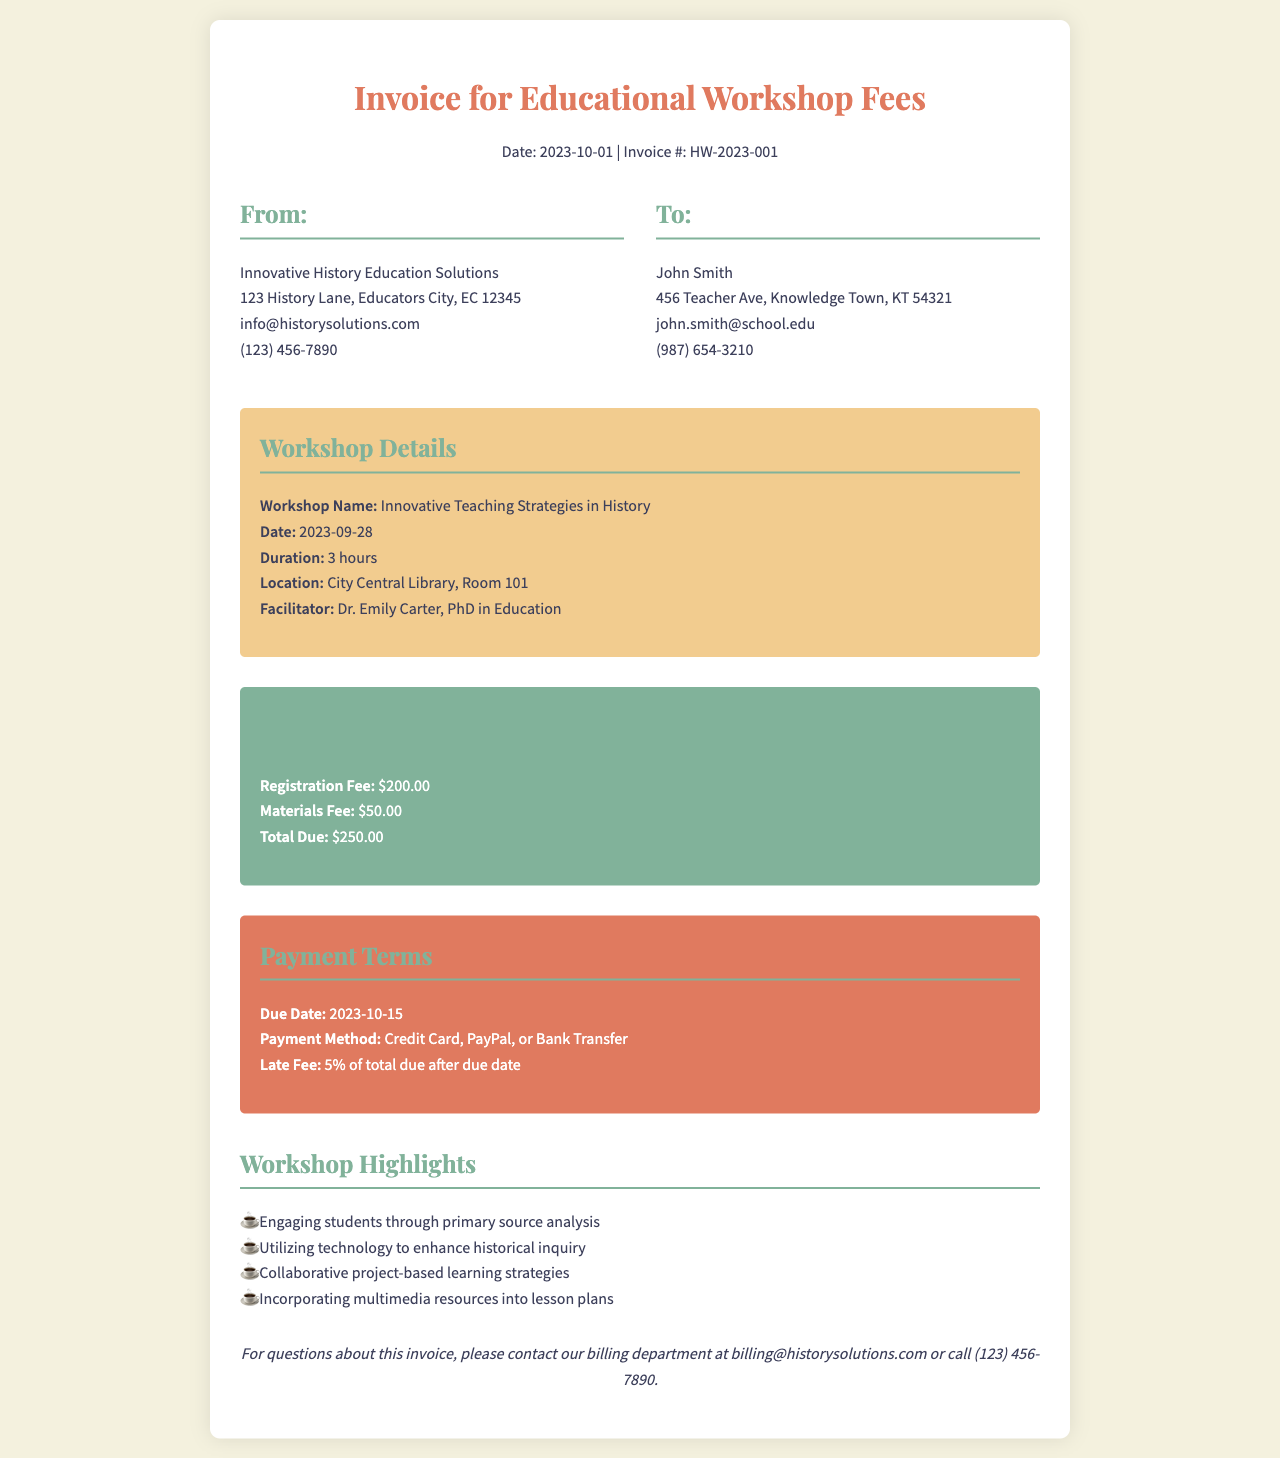What is the workshop name? The workshop name is clearly stated in the workshop details section of the invoice.
Answer: Innovative Teaching Strategies in History Who is the facilitator? The facilitator's name is mentioned under workshop details, indicating who led the workshop.
Answer: Dr. Emily Carter What is the total due amount? The total due amount is provided in the cost breakdown section of the invoice, summarizing the fees.
Answer: $250.00 What is the due date for payment? The due date for payment is specified in the payment terms section, outlining when payment must be made.
Answer: 2023-10-15 How much is the registration fee? The registration fee is detailed in the cost breakdown, showing the individual costs associated with the workshop.
Answer: $200.00 What location hosted the workshop? The location is stated in the workshop details, indicating where the event took place.
Answer: City Central Library, Room 101 What payment methods are accepted? The accepted payment methods are listed in the payment terms, guiding participants on how to pay.
Answer: Credit Card, PayPal, or Bank Transfer What is a workshop highlight related to technology? One of the workshop highlights mentions the use of technology in education, indicating its importance in the teaching strategies discussed.
Answer: Utilizing technology to enhance historical inquiry 